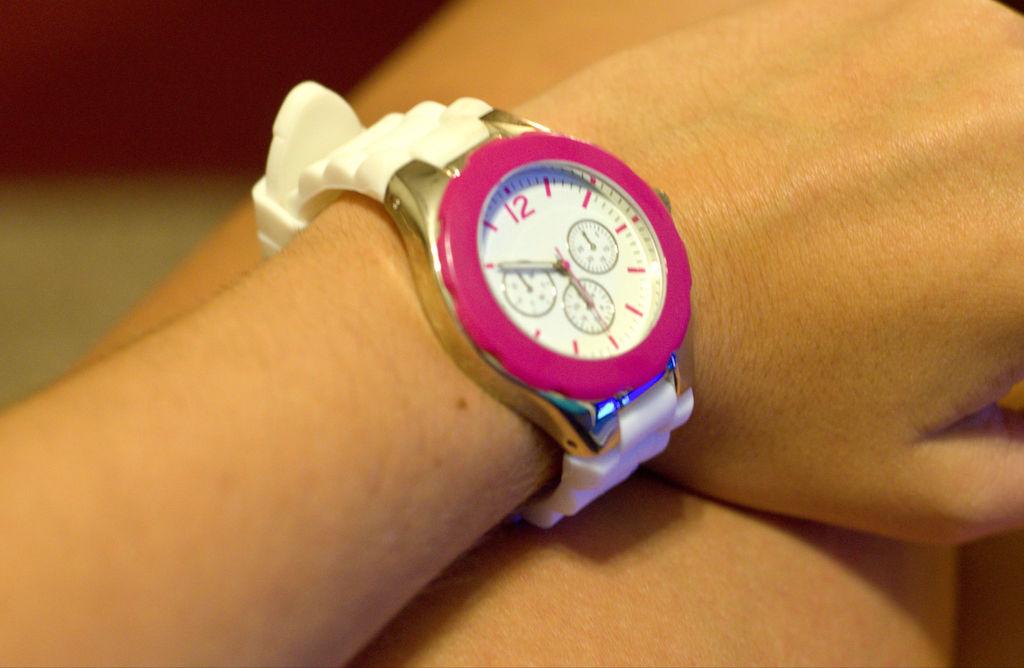What number is on the watch?
Offer a very short reply. 12. 